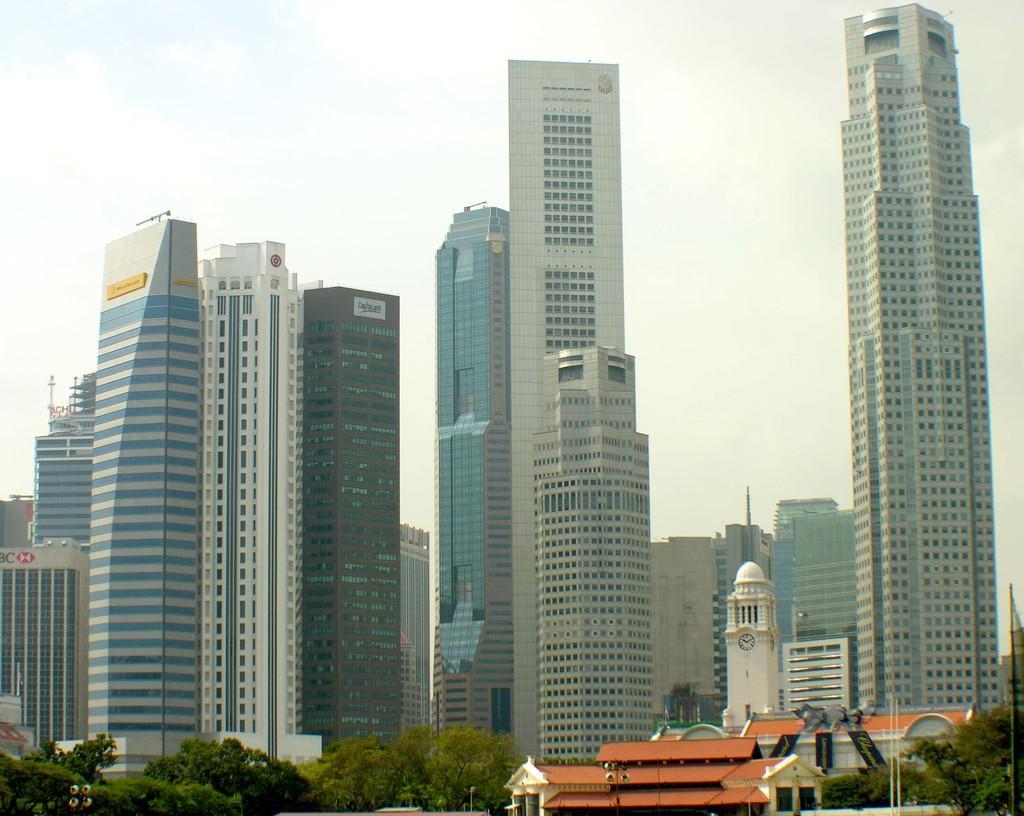Could you give a brief overview of what you see in this image? In this picture we can see buildings, trees, poles, some objects and in the background we can see the sky. 